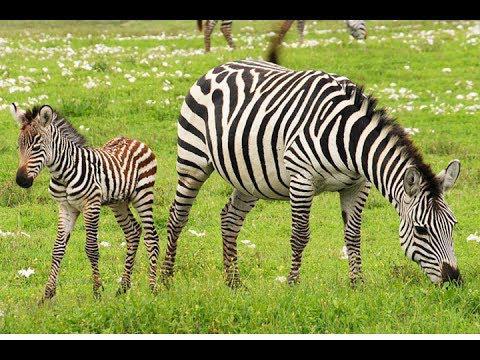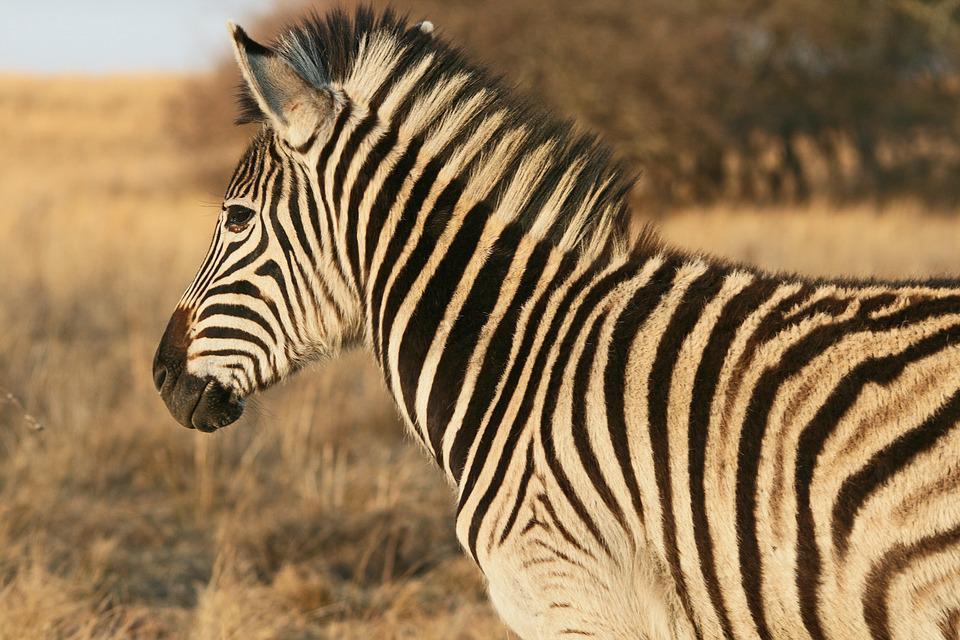The first image is the image on the left, the second image is the image on the right. For the images shown, is this caption "Two zebras are standing in the grass in at least one of the images." true? Answer yes or no. Yes. The first image is the image on the left, the second image is the image on the right. Considering the images on both sides, is "The left image shows a standing zebra colt with upright head next to a standing adult zebra with its head lowered to graze." valid? Answer yes or no. Yes. 